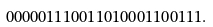<formula> <loc_0><loc_0><loc_500><loc_500>0 0 0 0 0 1 1 1 0 0 1 1 0 1 0 0 0 1 1 0 0 1 1 1 .</formula> 